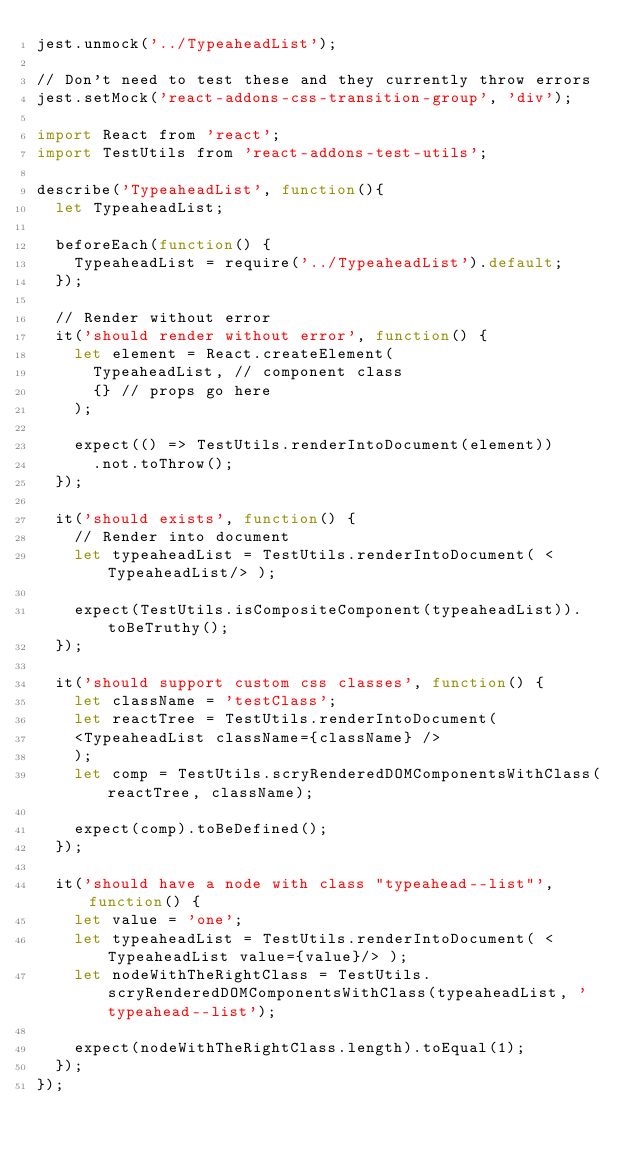Convert code to text. <code><loc_0><loc_0><loc_500><loc_500><_JavaScript_>jest.unmock('../TypeaheadList');

// Don't need to test these and they currently throw errors
jest.setMock('react-addons-css-transition-group', 'div');

import React from 'react';
import TestUtils from 'react-addons-test-utils';

describe('TypeaheadList', function(){
  let TypeaheadList;

  beforeEach(function() {
    TypeaheadList = require('../TypeaheadList').default;
  });

  // Render without error
  it('should render without error', function() {
    let element = React.createElement(
      TypeaheadList, // component class
      {} // props go here
    );

    expect(() => TestUtils.renderIntoDocument(element))
      .not.toThrow();
  });

  it('should exists', function() {
    // Render into document
    let typeaheadList = TestUtils.renderIntoDocument( <TypeaheadList/> );

    expect(TestUtils.isCompositeComponent(typeaheadList)).toBeTruthy();
  });

  it('should support custom css classes', function() {
    let className = 'testClass';
    let reactTree = TestUtils.renderIntoDocument(
    <TypeaheadList className={className} />
    );
    let comp = TestUtils.scryRenderedDOMComponentsWithClass(reactTree, className);

    expect(comp).toBeDefined();
  });

  it('should have a node with class "typeahead--list"', function() {
    let value = 'one';
    let typeaheadList = TestUtils.renderIntoDocument( <TypeaheadList value={value}/> );
    let nodeWithTheRightClass = TestUtils.scryRenderedDOMComponentsWithClass(typeaheadList, 'typeahead--list');

    expect(nodeWithTheRightClass.length).toEqual(1);
  });
});
</code> 